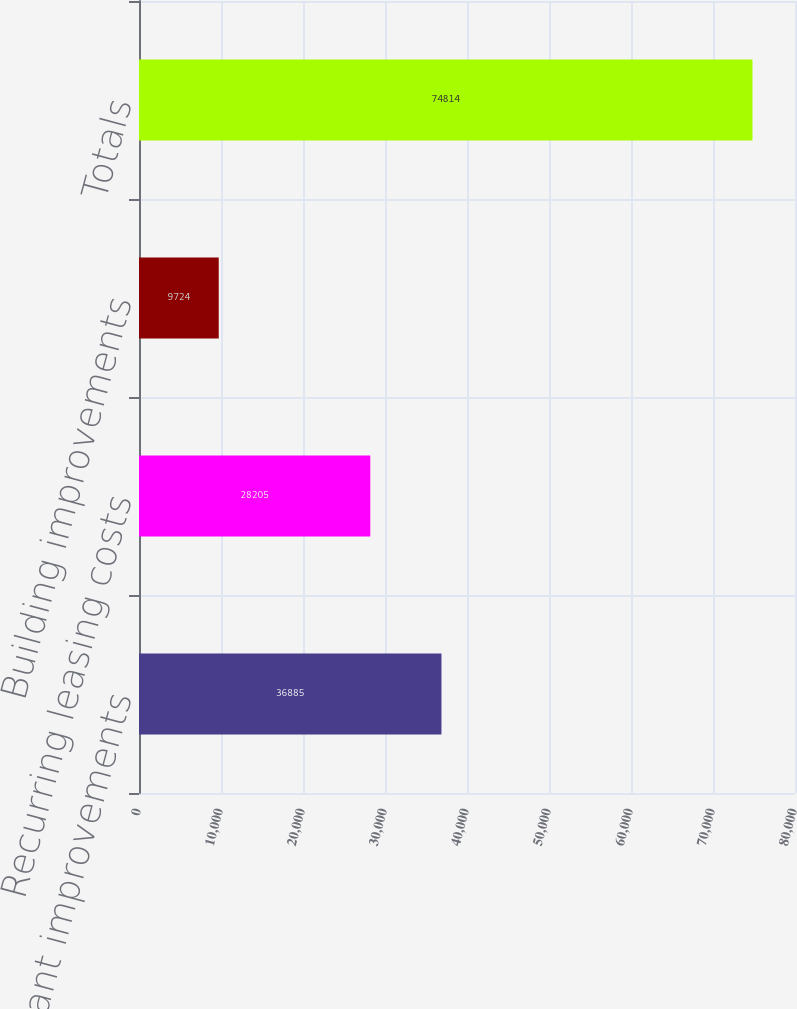<chart> <loc_0><loc_0><loc_500><loc_500><bar_chart><fcel>Recurring tenant improvements<fcel>Recurring leasing costs<fcel>Building improvements<fcel>Totals<nl><fcel>36885<fcel>28205<fcel>9724<fcel>74814<nl></chart> 